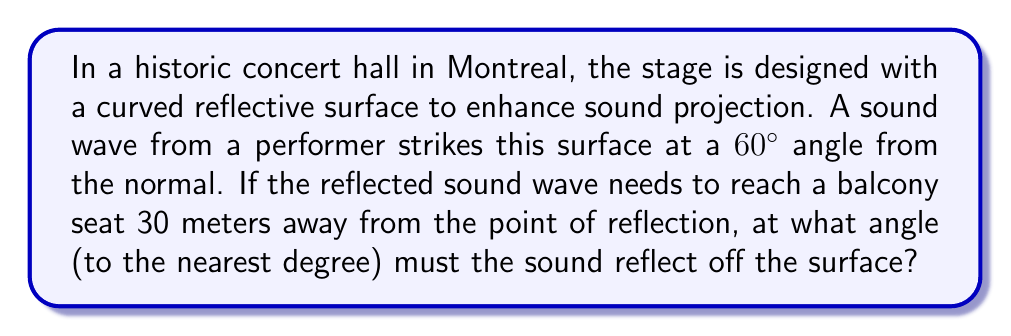Could you help me with this problem? Let's approach this step-by-step using the law of reflection and trigonometry:

1) First, recall the law of reflection: the angle of incidence equals the angle of reflection.

2) Given:
   - Angle of incidence = 60°
   - Distance to balcony seat = 30 meters

3) Let's define variables:
   - Let $\theta$ be the angle of reflection (which we need to find)
   - Let $x$ be the horizontal distance from the reflection point to the balcony seat

4) We can draw a right triangle where:
   - The hypotenuse is 30 meters (distance to balcony seat)
   - One angle is $\theta$ (the angle of reflection)

5) Using trigonometry:

   $$\cos \theta = \frac{x}{30}$$

6) We know that the total angle between the incident and reflected waves is 120° (60° + 60°), so:

   $$\theta = 120° - 60° = 60°$$

7) Now we can solve for $x$:

   $$x = 30 \cos 60° = 30 \cdot 0.5 = 15\text{ meters}$$

8) To verify, we can check if this forms a 30-60-90 triangle:
   - Horizontal side: 15 meters
   - Vertical side: $30 \sin 60° = 30 \cdot \frac{\sqrt{3}}{2} \approx 25.98\text{ meters}$
   - Hypotenuse: 30 meters

   This indeed forms a 30-60-90 triangle, confirming our solution.

[asy]
import geometry;

size(200);

pair A = (0,0);
pair B = (5,0);
pair C = (0,8.66);

draw(A--B--C--A);

label("30m", C--A, W);
label("15m", A--B, S);
label("60°", A, NE);

draw(A--(0,1), dashed);
draw(arc(A,0.8,0,60), Arrow);
[/asy]
Answer: 60° 